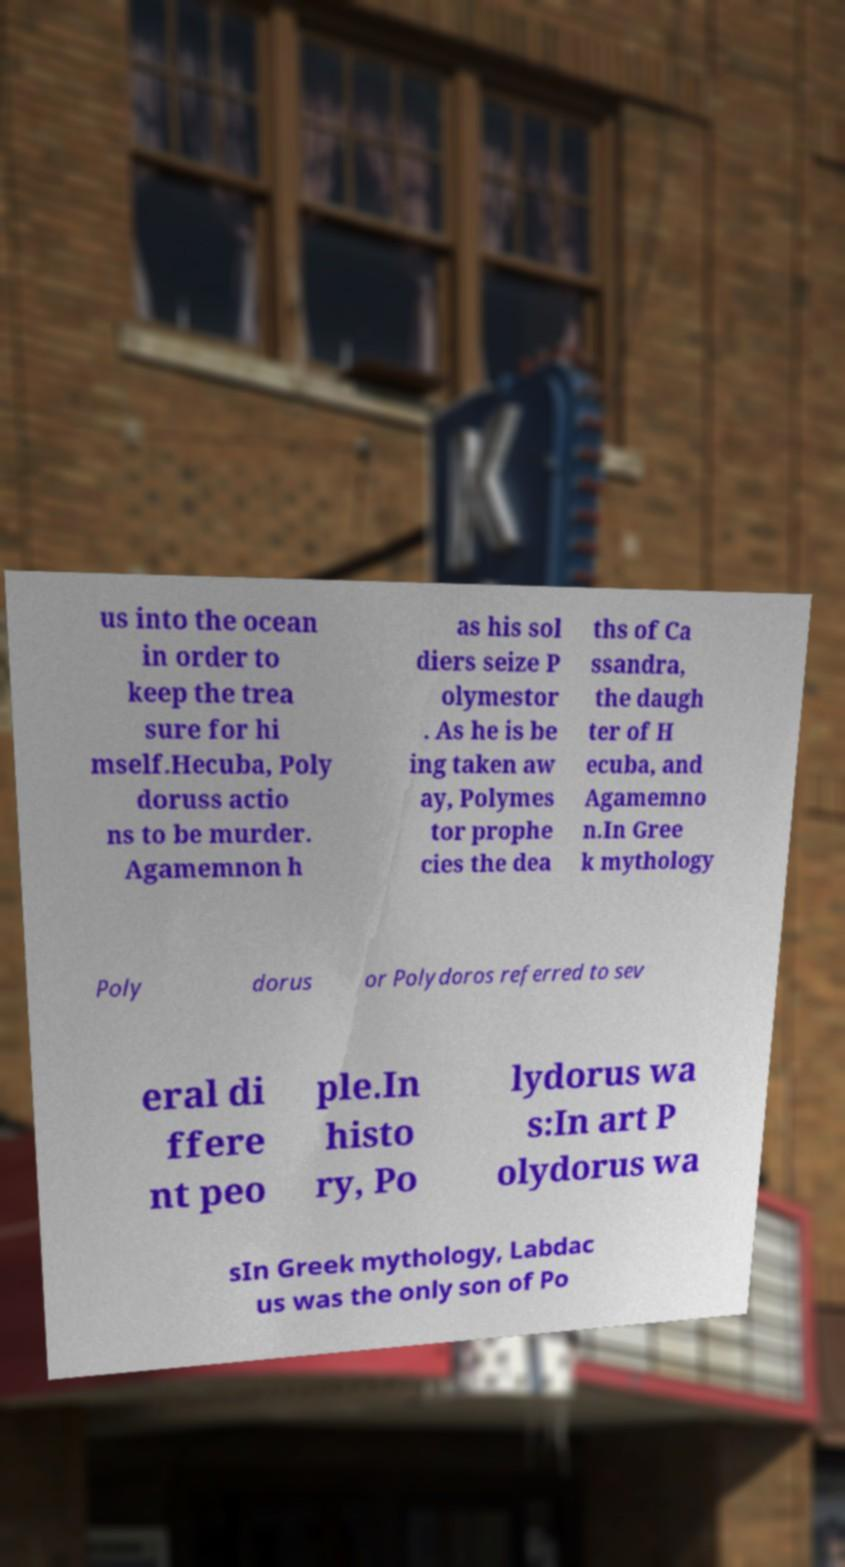For documentation purposes, I need the text within this image transcribed. Could you provide that? us into the ocean in order to keep the trea sure for hi mself.Hecuba, Poly doruss actio ns to be murder. Agamemnon h as his sol diers seize P olymestor . As he is be ing taken aw ay, Polymes tor prophe cies the dea ths of Ca ssandra, the daugh ter of H ecuba, and Agamemno n.In Gree k mythology Poly dorus or Polydoros referred to sev eral di ffere nt peo ple.In histo ry, Po lydorus wa s:In art P olydorus wa sIn Greek mythology, Labdac us was the only son of Po 